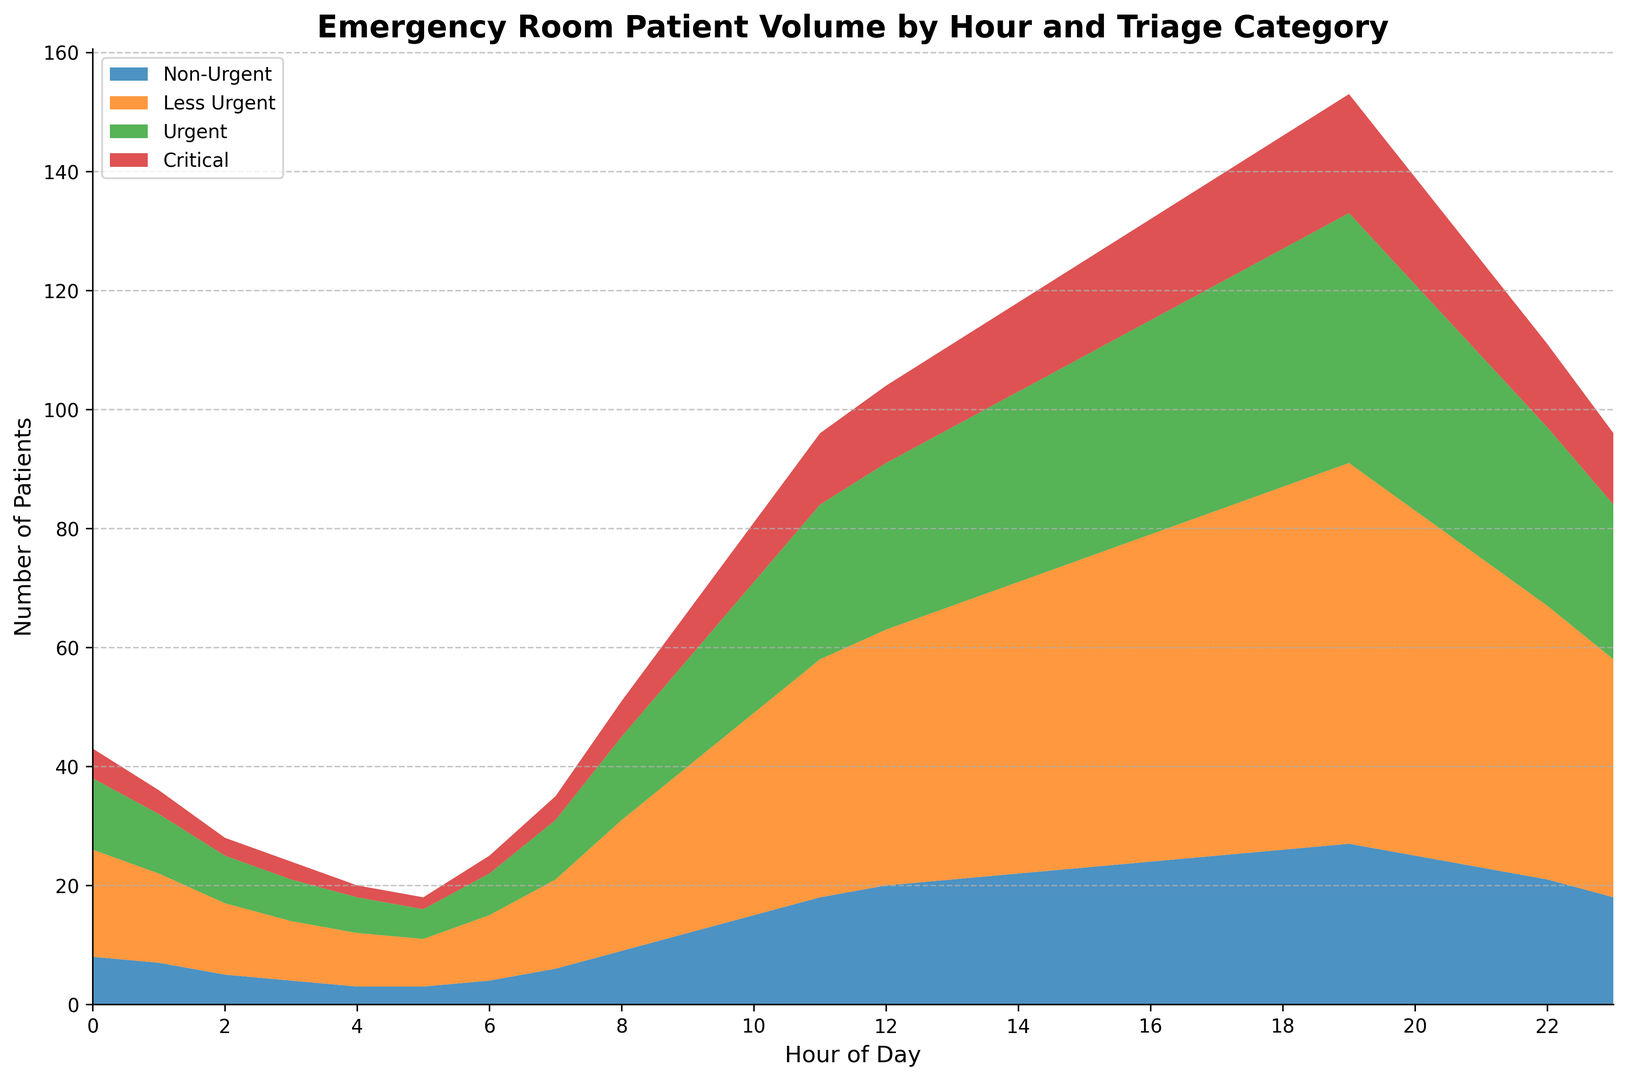What hour has the highest number of Critical patients? Look for the hour where the 'Critical' section in the area chart reaches its peak.
Answer: 19 What is the difference in the total number of patients between 14:00 and 3:00? Sum the patients at 14:00 for all categories (15+32+49+22) and at 3:00 (3+7+10+4). Then subtract the total at 3:00 from the total at 14:00.
Answer: 105 - 24 = 81 Which category shows the greatest increase in volume from 12:00 to 16:00? Compare the total increase in each category from 12:00 to 16:00: Subtract the values at 12:00 from those at 16:00 for each category.
Answer: Less Urgent (55 - 43 = 12) During which hour does the Non-Urgent category have the lowest patient volume? Identify the hour with the smallest section size for Non-Urgent in the area chart.
Answer: 4:00, 5:00 How does the patient volume change between 0:00 and 8:00 for the Urgent category? Observe the changes in the 'Urgent' section of the area chart between these hours: 8 at 2:00, gradually increasing and reaching 14 by 8:00.
Answer: Increases What is the average number of patients per hour in the Less Urgent category from 18:00 to 22:00? Summing the values for Less Urgent from 18:00 to 22:00 (62+58+52+46+46) and then divide by the number of hours (5).
Answer: 58.8 Which hour has the lowest total patient volume, and what is that volume? Examine the sum of all categories for each hour and find the smallest sum.
Answer: 4:00, 20 How does the volume of Critical patients at 10:00 compare to 22:00? Check the values for the Critical category at these times (10 at 10:00 and 14 at 22:00). Determine if one is greater, less than, or equal to the other.
Answer: Less at 10:00 If you add the number of Urgent patients at 9:00 and 15:00, what is the total? Sum the 'Urgent' category for both hours.
Answer: 18 + 34 = 52 